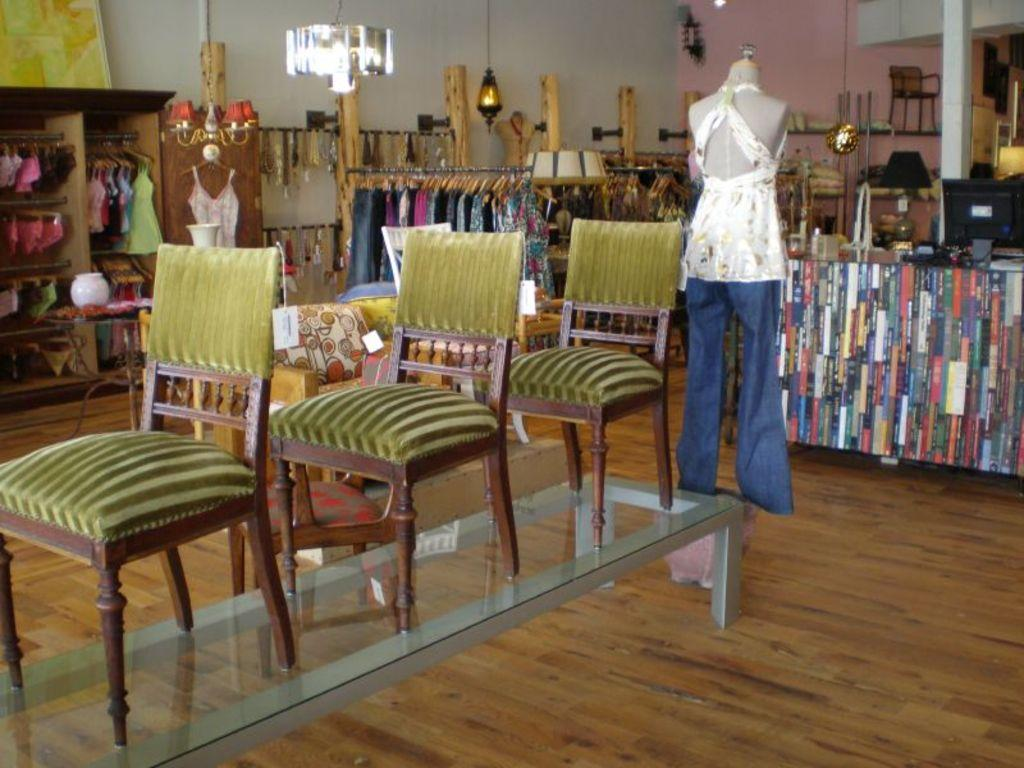What type of furniture is present in the image? There are chairs in the image. What other object can be seen in the image? There is a mannequin in the image. What storage unit is visible in the image? There is a cupboard in the image. Can you describe the system at the back side of the image? Unfortunately, the facts provided do not give any information about the system at the back side of the image. How many pieces of paper are on the floor near the mannequin? There is no information about paper in the image, so we cannot determine the number of pieces on the floor. Is the mannequin holding a whip in the image? There is no mention of a whip in the image, so we cannot determine if the mannequin is holding one. 